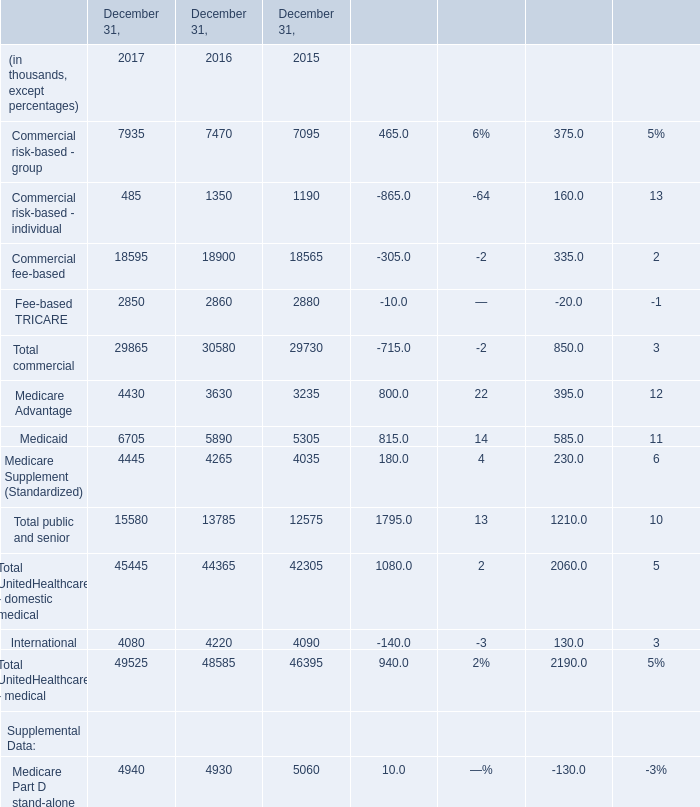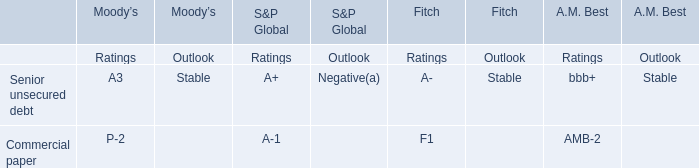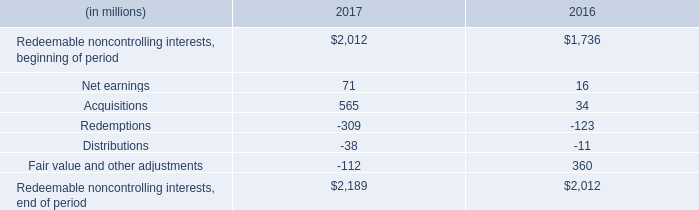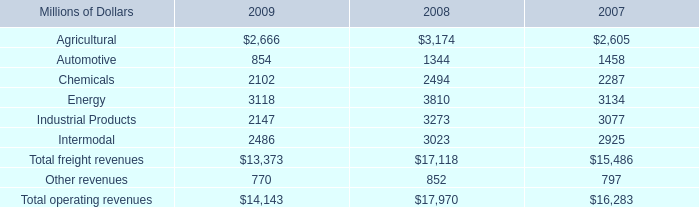What's the total amount of the Medicaid in the years where Commercial risk-based - individual greater than 1000? (in thousand) 
Computations: (5890 + 5305)
Answer: 11195.0. 